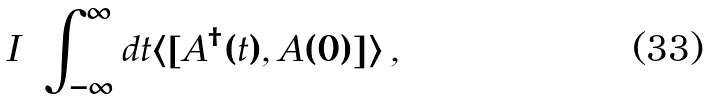<formula> <loc_0><loc_0><loc_500><loc_500>I = \int _ { - \infty } ^ { \infty } d t \langle [ A ^ { \dagger } ( t ) , A ( 0 ) ] \rangle \, ,</formula> 